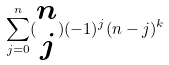<formula> <loc_0><loc_0><loc_500><loc_500>\sum _ { j = 0 } ^ { n } ( \begin{matrix} n \\ j \end{matrix} ) ( - 1 ) ^ { j } ( n - j ) ^ { k }</formula> 